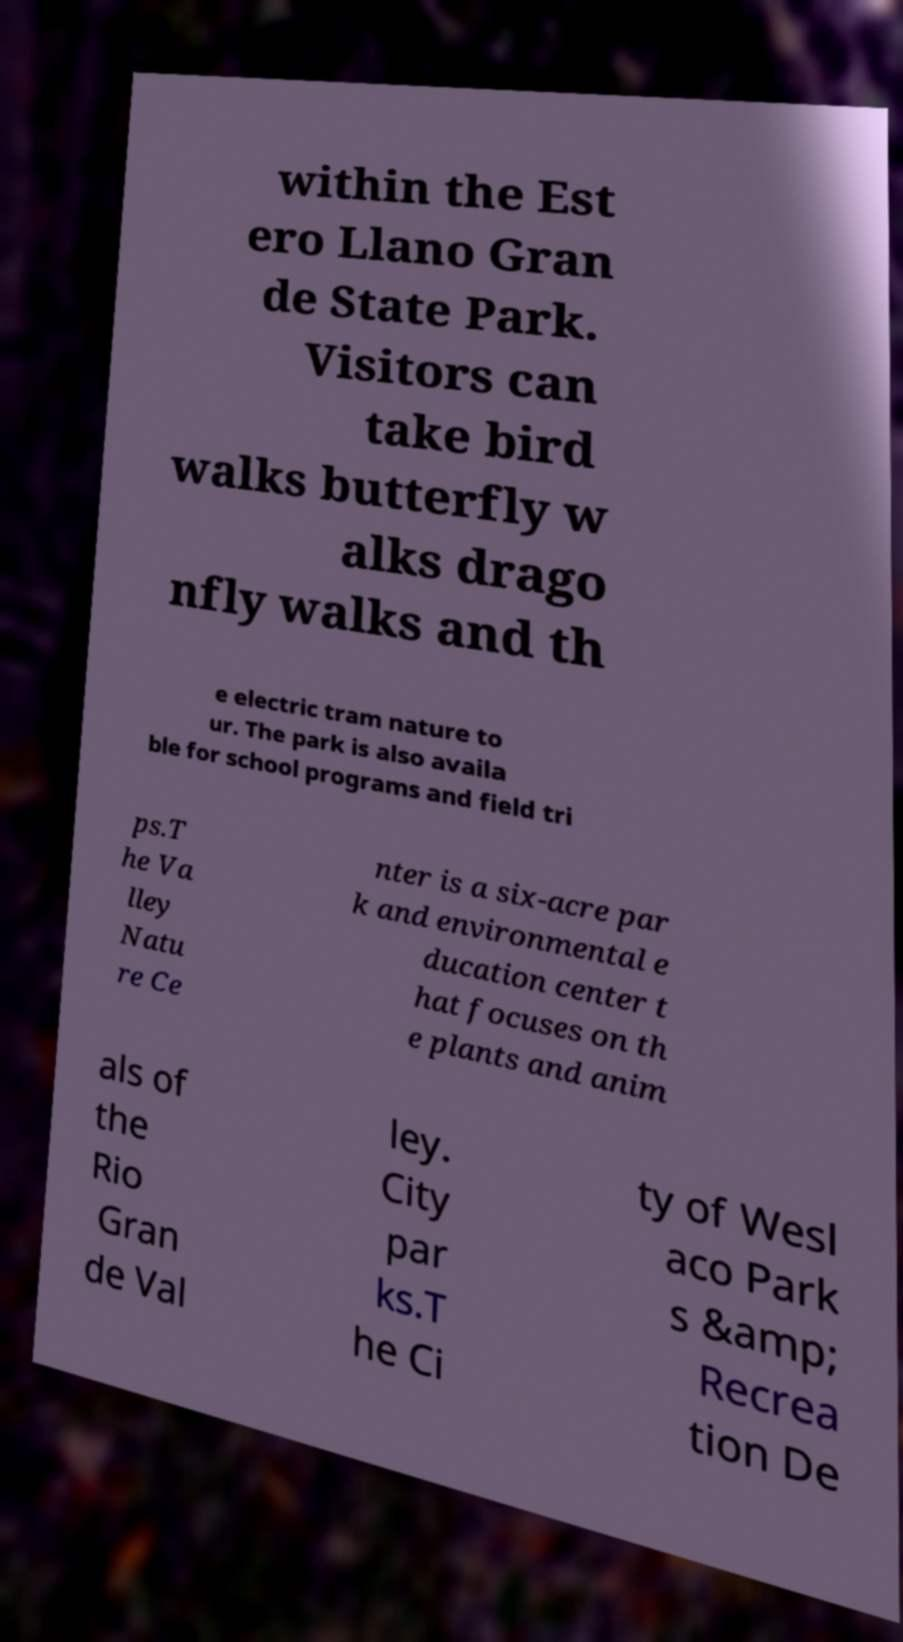Please identify and transcribe the text found in this image. within the Est ero Llano Gran de State Park. Visitors can take bird walks butterfly w alks drago nfly walks and th e electric tram nature to ur. The park is also availa ble for school programs and field tri ps.T he Va lley Natu re Ce nter is a six-acre par k and environmental e ducation center t hat focuses on th e plants and anim als of the Rio Gran de Val ley. City par ks.T he Ci ty of Wesl aco Park s &amp; Recrea tion De 